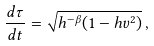<formula> <loc_0><loc_0><loc_500><loc_500>\frac { d \tau } { d t } = \sqrt { h ^ { - \beta } ( 1 - h v ^ { 2 } ) } \, ,</formula> 